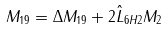Convert formula to latex. <formula><loc_0><loc_0><loc_500><loc_500>M _ { 1 9 } & = \Delta M _ { 1 9 } + 2 \hat { L } _ { 6 H 2 } M _ { 2 }</formula> 